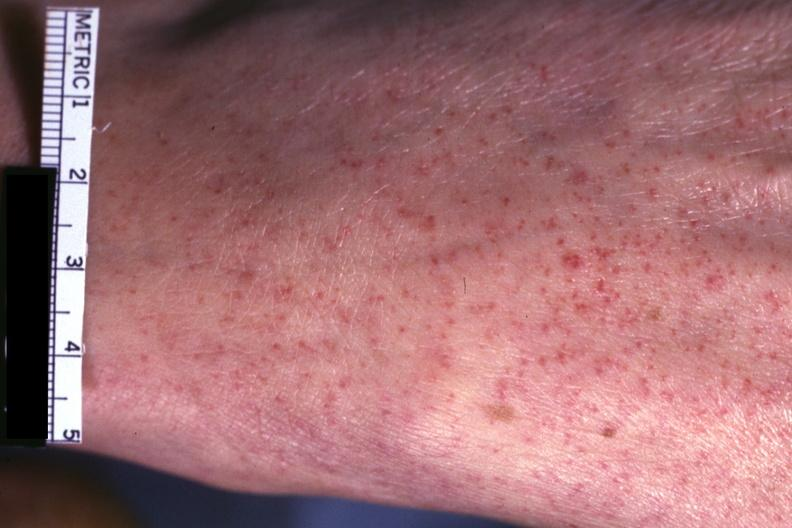where is this?
Answer the question using a single word or phrase. Skin 